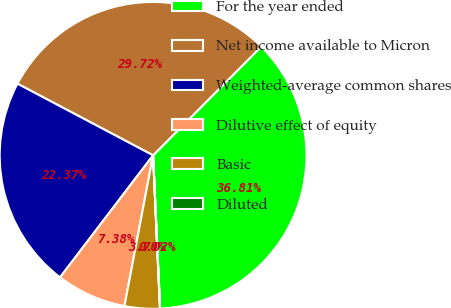<chart> <loc_0><loc_0><loc_500><loc_500><pie_chart><fcel>For the year ended<fcel>Net income available to Micron<fcel>Weighted-average common shares<fcel>Dilutive effect of equity<fcel>Basic<fcel>Diluted<nl><fcel>36.81%<fcel>29.72%<fcel>22.37%<fcel>7.38%<fcel>3.7%<fcel>0.02%<nl></chart> 